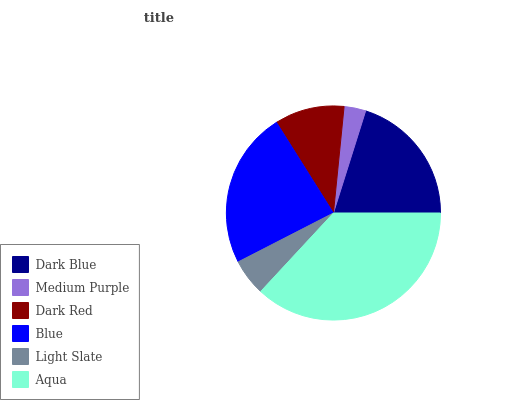Is Medium Purple the minimum?
Answer yes or no. Yes. Is Aqua the maximum?
Answer yes or no. Yes. Is Dark Red the minimum?
Answer yes or no. No. Is Dark Red the maximum?
Answer yes or no. No. Is Dark Red greater than Medium Purple?
Answer yes or no. Yes. Is Medium Purple less than Dark Red?
Answer yes or no. Yes. Is Medium Purple greater than Dark Red?
Answer yes or no. No. Is Dark Red less than Medium Purple?
Answer yes or no. No. Is Dark Blue the high median?
Answer yes or no. Yes. Is Dark Red the low median?
Answer yes or no. Yes. Is Medium Purple the high median?
Answer yes or no. No. Is Blue the low median?
Answer yes or no. No. 